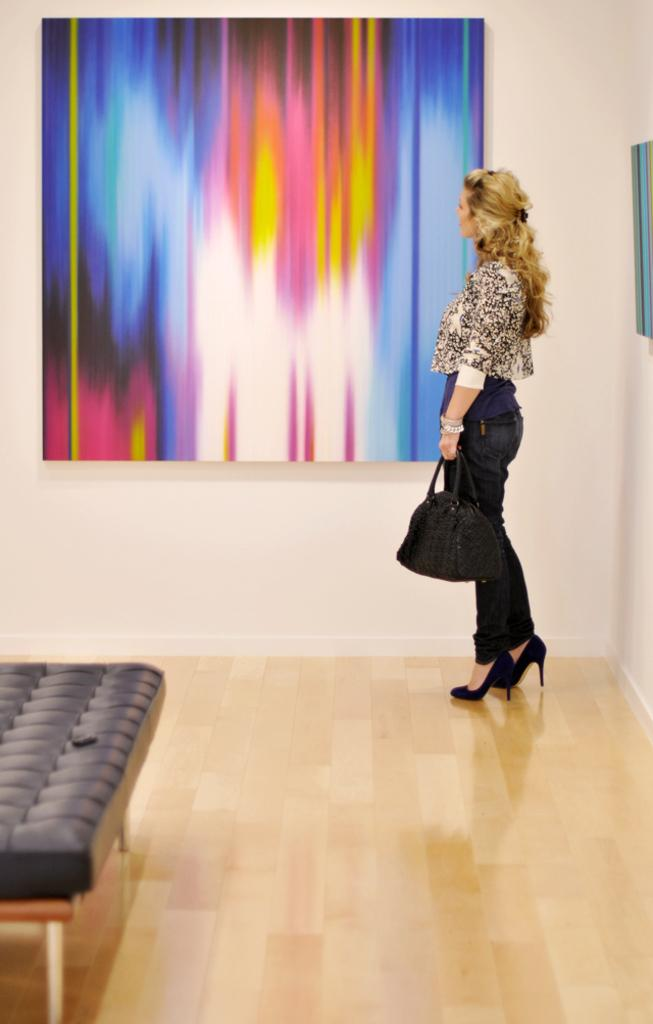Who is present in the image? There is a woman in the image. What is the woman holding in her hand? The woman is carrying a bag in her hand. How is the woman dressed? The woman is wearing a nice dress. What is the woman looking at? The woman is looking at a wall. What can be seen on the wall? There are paintings on the wall. What type of furniture is on the floor in the image? There is a bed on the floor in the image. What verse can be heard being recited by the rat in the image? There is no rat present in the image, and therefore no verse can be heard being recited. 